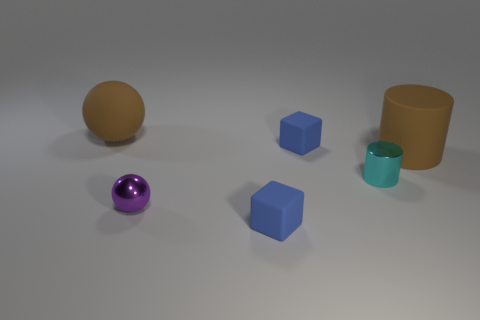Subtract all balls. How many objects are left? 4 Subtract all brown cylinders. How many cylinders are left? 1 Subtract 0 gray cubes. How many objects are left? 6 Subtract 2 cylinders. How many cylinders are left? 0 Subtract all green balls. Subtract all green cubes. How many balls are left? 2 Subtract all green blocks. How many green balls are left? 0 Subtract all brown matte things. Subtract all tiny cyan metallic things. How many objects are left? 3 Add 4 matte cubes. How many matte cubes are left? 6 Add 6 cyan things. How many cyan things exist? 7 Add 2 spheres. How many objects exist? 8 